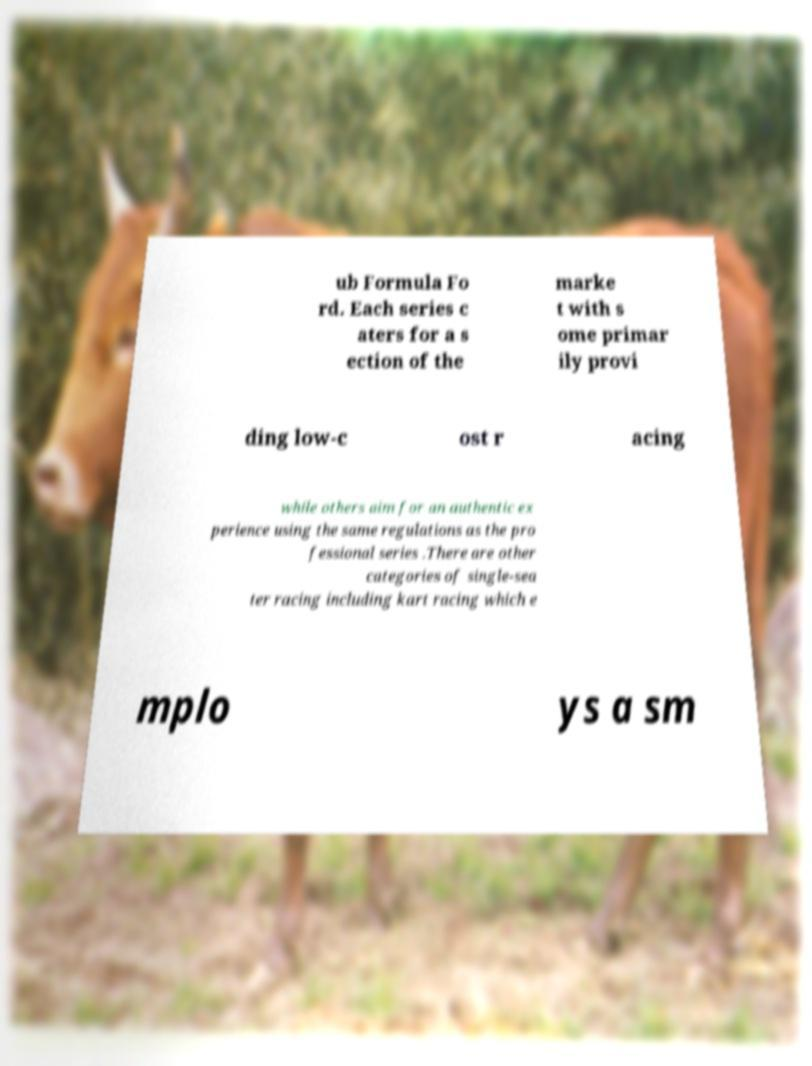For documentation purposes, I need the text within this image transcribed. Could you provide that? ub Formula Fo rd. Each series c aters for a s ection of the marke t with s ome primar ily provi ding low-c ost r acing while others aim for an authentic ex perience using the same regulations as the pro fessional series .There are other categories of single-sea ter racing including kart racing which e mplo ys a sm 